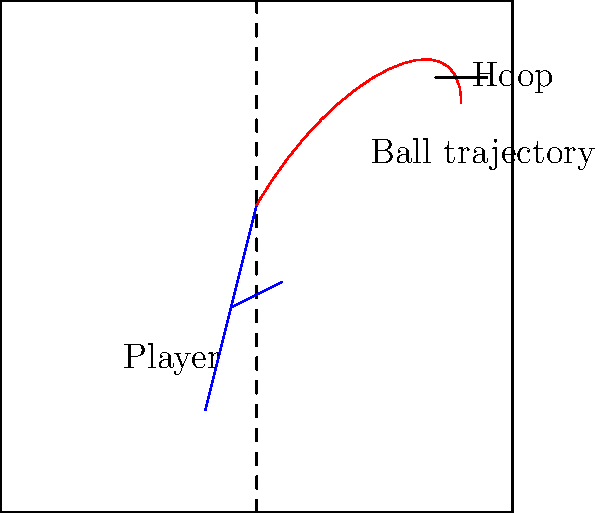Based on the image showing a basketball player's stance and arm position, which machine learning technique would be most suitable for predicting the trajectory of the shot?
A) Convolutional Neural Networks (CNN)
B) Random Forest
C) Support Vector Machines (SVM)
D) K-Nearest Neighbors (KNN) Let's break this down step-by-step:

1. The image provides visual information about the player's stance and arm position, which are crucial for predicting the shot trajectory.

2. We need a machine learning technique that excels at processing and analyzing visual data.

3. Convolutional Neural Networks (CNNs) are specifically designed for image processing tasks. They can:
   a) Automatically detect important features in images
   b) Learn spatial hierarchies of patterns
   c) Be highly effective in computer vision tasks

4. Other options:
   - Random Forest: Good for general-purpose prediction, but not specialized for image data
   - SVM: Can work with image data but less effective than CNNs for complex visual tasks
   - KNN: Simple algorithm, not ideal for high-dimensional image data

5. CNNs can learn to recognize patterns in player stance, arm angle, and ball position that correlate with different shot trajectories.

6. In a real-world application, you'd train the CNN on thousands of images of players shooting, paired with the resulting trajectories.

7. Once trained, the CNN could take a new image of a player's shot and predict the likely trajectory, which is exactly what we need for this task.
Answer: A) Convolutional Neural Networks (CNN) 